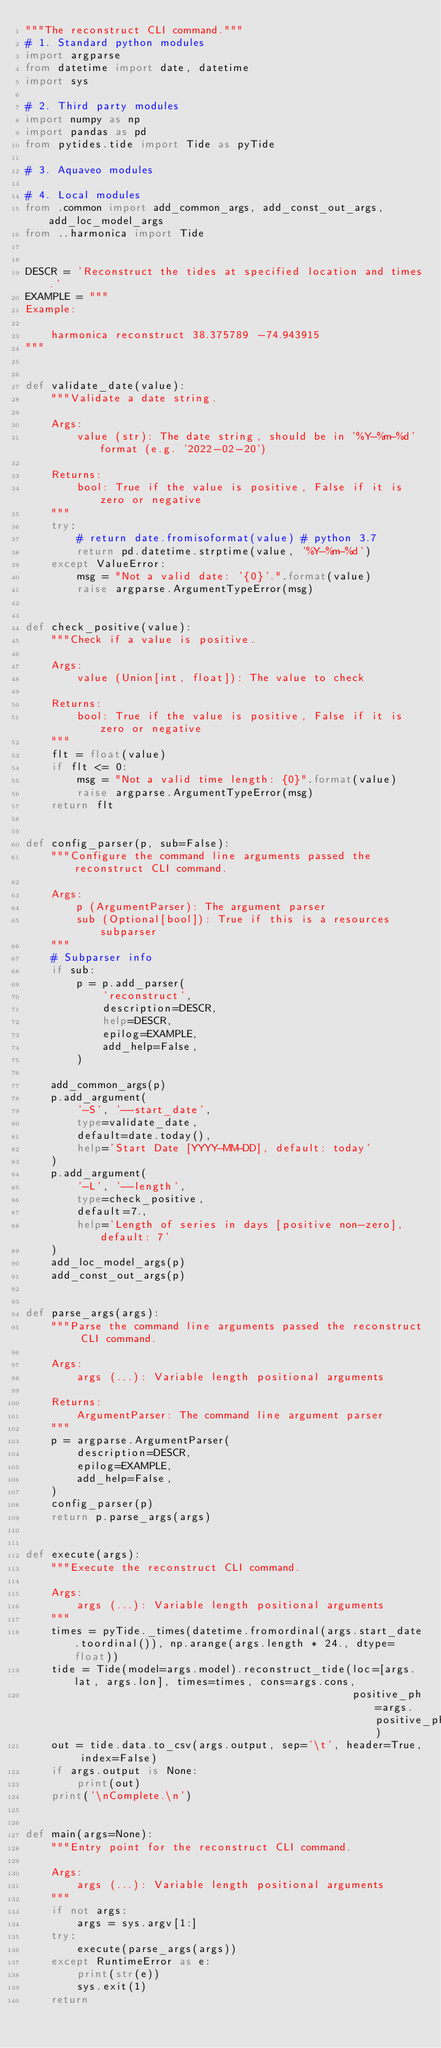<code> <loc_0><loc_0><loc_500><loc_500><_Python_>"""The reconstruct CLI command."""
# 1. Standard python modules
import argparse
from datetime import date, datetime
import sys

# 2. Third party modules
import numpy as np
import pandas as pd
from pytides.tide import Tide as pyTide

# 3. Aquaveo modules

# 4. Local modules
from .common import add_common_args, add_const_out_args, add_loc_model_args
from ..harmonica import Tide


DESCR = 'Reconstruct the tides at specified location and times.'
EXAMPLE = """
Example:

    harmonica reconstruct 38.375789 -74.943915
"""


def validate_date(value):
    """Validate a date string.

    Args:
        value (str): The date string, should be in '%Y-%m-%d' format (e.g. '2022-02-20')

    Returns:
        bool: True if the value is positive, False if it is zero or negative
    """
    try:
        # return date.fromisoformat(value) # python 3.7
        return pd.datetime.strptime(value, '%Y-%m-%d')
    except ValueError:
        msg = "Not a valid date: '{0}'.".format(value)
        raise argparse.ArgumentTypeError(msg)


def check_positive(value):
    """Check if a value is positive.

    Args:
        value (Union[int, float]): The value to check

    Returns:
        bool: True if the value is positive, False if it is zero or negative
    """
    flt = float(value)
    if flt <= 0:
        msg = "Not a valid time length: {0}".format(value)
        raise argparse.ArgumentTypeError(msg)
    return flt


def config_parser(p, sub=False):
    """Configure the command line arguments passed the reconstruct CLI command.

    Args:
        p (ArgumentParser): The argument parser
        sub (Optional[bool]): True if this is a resources subparser
    """
    # Subparser info
    if sub:
        p = p.add_parser(
            'reconstruct',
            description=DESCR,
            help=DESCR,
            epilog=EXAMPLE,
            add_help=False,
        )

    add_common_args(p)
    p.add_argument(
        '-S', '--start_date',
        type=validate_date,
        default=date.today(),
        help='Start Date [YYYY-MM-DD], default: today'
    )
    p.add_argument(
        '-L', '--length',
        type=check_positive,
        default=7.,
        help='Length of series in days [positive non-zero], default: 7'
    )
    add_loc_model_args(p)
    add_const_out_args(p)


def parse_args(args):
    """Parse the command line arguments passed the reconstruct CLI command.

    Args:
        args (...): Variable length positional arguments

    Returns:
        ArgumentParser: The command line argument parser
    """
    p = argparse.ArgumentParser(
        description=DESCR,
        epilog=EXAMPLE,
        add_help=False,
    )
    config_parser(p)
    return p.parse_args(args)


def execute(args):
    """Execute the reconstruct CLI command.

    Args:
        args (...): Variable length positional arguments
    """
    times = pyTide._times(datetime.fromordinal(args.start_date.toordinal()), np.arange(args.length * 24., dtype=float))
    tide = Tide(model=args.model).reconstruct_tide(loc=[args.lat, args.lon], times=times, cons=args.cons,
                                                   positive_ph=args.positive_phase)
    out = tide.data.to_csv(args.output, sep='\t', header=True, index=False)
    if args.output is None:
        print(out)
    print('\nComplete.\n')


def main(args=None):
    """Entry point for the reconstruct CLI command.

    Args:
        args (...): Variable length positional arguments
    """
    if not args:
        args = sys.argv[1:]
    try:
        execute(parse_args(args))
    except RuntimeError as e:
        print(str(e))
        sys.exit(1)
    return
</code> 